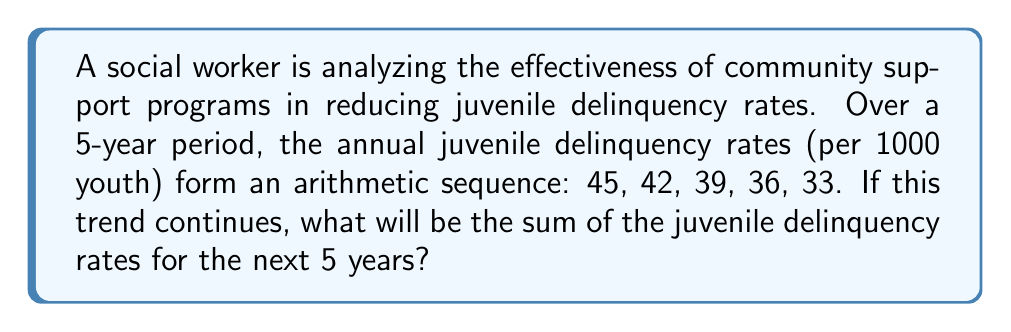Give your solution to this math problem. Let's approach this step-by-step:

1) First, we need to identify the arithmetic sequence:
   $a_1 = 45$, $a_2 = 42$, $a_3 = 39$, $a_4 = 36$, $a_5 = 33$

2) Calculate the common difference (d):
   $d = a_2 - a_1 = 42 - 45 = -3$

3) The sequence is decreasing by 3 each year. We need to find the next 5 terms:
   $a_6 = 33 - 3 = 30$
   $a_7 = 30 - 3 = 27$
   $a_8 = 27 - 3 = 24$
   $a_9 = 24 - 3 = 21$
   $a_{10} = 21 - 3 = 18$

4) Now we need to find the sum of these 5 terms. We can use the arithmetic sequence sum formula:

   $$S_n = \frac{n}{2}(a_1 + a_n)$$

   Where $n = 5$, $a_1 = 30$ (the 6th term overall, but 1st of the next 5), and $a_n = a_5 = 18$

5) Plugging into the formula:

   $$S_5 = \frac{5}{2}(30 + 18) = \frac{5}{2}(48) = 5(24) = 120$$

Therefore, the sum of the juvenile delinquency rates for the next 5 years will be 120 per 1000 youth.
Answer: 120 